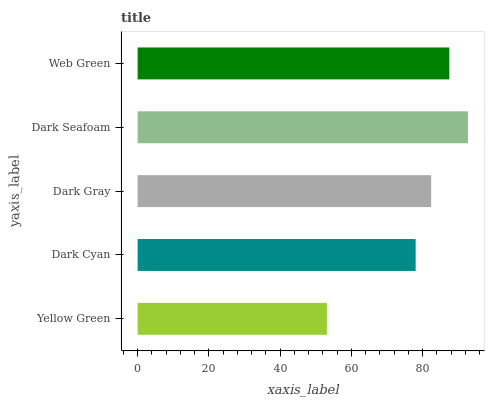Is Yellow Green the minimum?
Answer yes or no. Yes. Is Dark Seafoam the maximum?
Answer yes or no. Yes. Is Dark Cyan the minimum?
Answer yes or no. No. Is Dark Cyan the maximum?
Answer yes or no. No. Is Dark Cyan greater than Yellow Green?
Answer yes or no. Yes. Is Yellow Green less than Dark Cyan?
Answer yes or no. Yes. Is Yellow Green greater than Dark Cyan?
Answer yes or no. No. Is Dark Cyan less than Yellow Green?
Answer yes or no. No. Is Dark Gray the high median?
Answer yes or no. Yes. Is Dark Gray the low median?
Answer yes or no. Yes. Is Dark Cyan the high median?
Answer yes or no. No. Is Dark Cyan the low median?
Answer yes or no. No. 